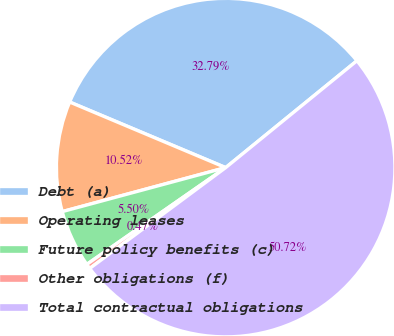Convert chart. <chart><loc_0><loc_0><loc_500><loc_500><pie_chart><fcel>Debt (a)<fcel>Operating leases<fcel>Future policy benefits (c)<fcel>Other obligations (f)<fcel>Total contractual obligations<nl><fcel>32.79%<fcel>10.52%<fcel>5.5%<fcel>0.47%<fcel>50.72%<nl></chart> 